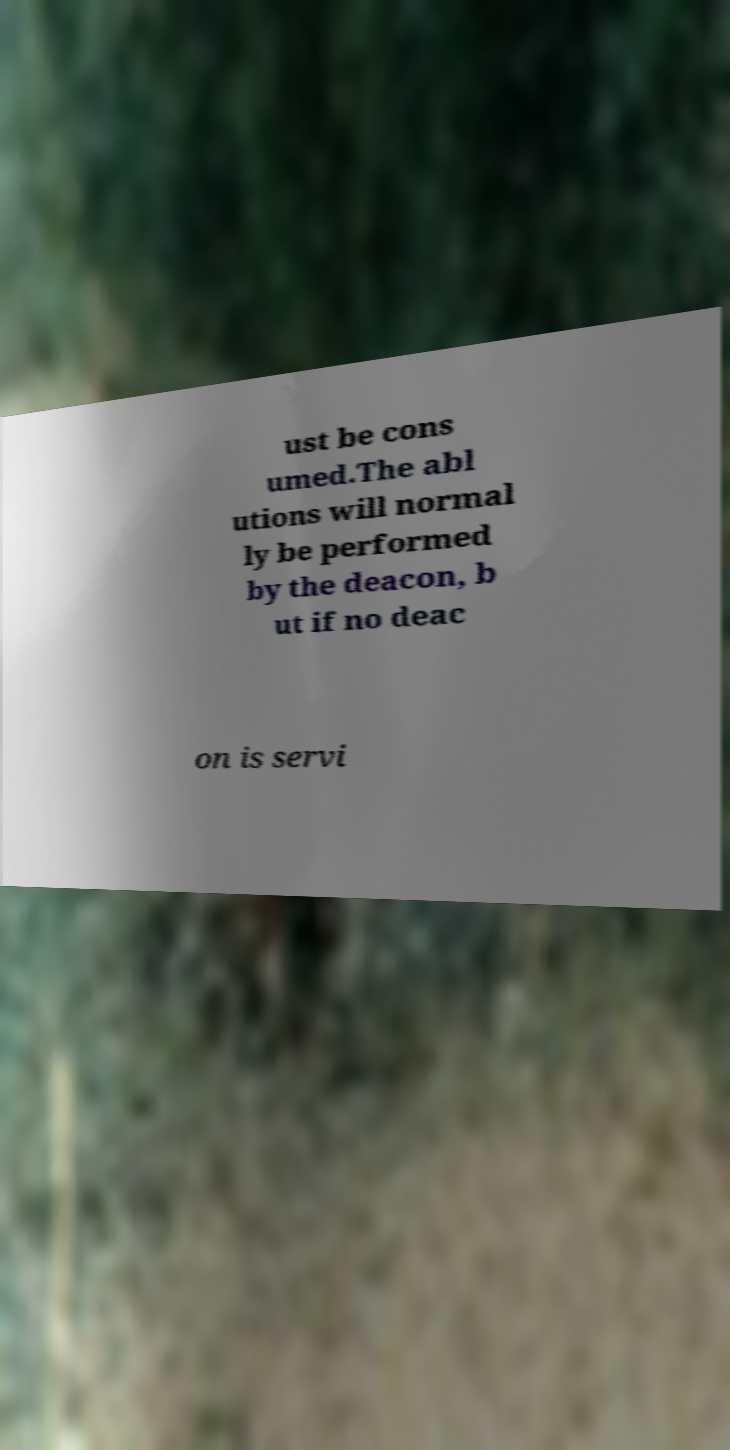Please identify and transcribe the text found in this image. ust be cons umed.The abl utions will normal ly be performed by the deacon, b ut if no deac on is servi 